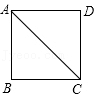In the given diagram, if AB in square ABCD is equal to 1 unit, what is the length of AC? To determine the length of diagonal AC in the square ABCD, where each side (AB, BC, CD, and DA) measures 1 unit, we apply the Pythagorean Theorem to triangle ABC. Since AB and BC are both 1 unit, AC, which is the hypotenuse of right triangle ABC, would be calculated as follows: AC = sqrt(AB^2 + BC^2) = sqrt(1^2 + 1^2) = sqrt(2). Thus, the measure of diagonal AC is sqrt(2), which corresponds to choice B. 